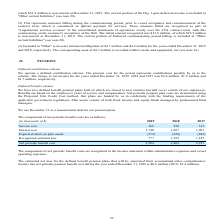From Golar Lng's financial document, What are the components of net periodic benefit costs? The document contains multiple relevant values: Service cost, Interest cost, Expected return on plan assets, Recognized actuarial loss. From the document: "nds of $) 2019 2018 2017 Service cost 162 250 313 Interest cost 1,740 1,687 1,901 Expected return on plan assets (375) (926) (843) Recognized actuaria..." Also, How are net periodic pension plan costs determined? Using the Projected Unit Credit Cost method. The document states: "n. Net periodic pension plan costs are determined using the Projected Unit Credit Cost method. Our plans are funded by us in conformity with the fundi..." Also, What does plan assets comprise of? Fixed income and equity funds managed by professional fund managers. The document states: "vernment regulations. Plan assets consist of both fixed income and equity funds managed by professional fund managers. vernment regulations. Plan asse..." Additionally, Which year was the interest cost the lowest? According to the financial document, 2018. The relevant text states: "(in thousands of $) 2019 2018 2017 Service cost 162 250 313 Interest cost 1,740 1,687 1,901 Expected return on plan assets (375)..." Also, can you calculate: What was the change in service cost from 2017 to 2018? Based on the calculation: 250 - 313 , the result is -63 (in thousands). This is based on the information: "n thousands of $) 2019 2018 2017 Service cost 162 250 313 Interest cost 1,740 1,687 1,901 Expected return on plan assets (375) (926) (843) Recognized act ousands of $) 2019 2018 2017 Service cost 162 ..." The key data points involved are: 250, 313. Also, can you calculate: What was the percentage change in net periodic benefit cost from 2018 to 2019? To answer this question, I need to perform calculations using the financial data. The calculation is: (2,304 - 2,403)/2,403 , which equals -4.12 (percentage). This is based on the information: "s 777 1,392 1,182 Net periodic benefit cost 2,304 2,403 2,553 al loss 777 1,392 1,182 Net periodic benefit cost 2,304 2,403 2,553..." The key data points involved are: 2,304, 2,403. 